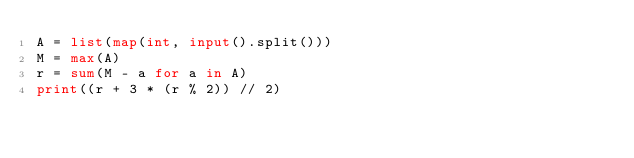Convert code to text. <code><loc_0><loc_0><loc_500><loc_500><_Python_>A = list(map(int, input().split()))
M = max(A)
r = sum(M - a for a in A)
print((r + 3 * (r % 2)) // 2)</code> 